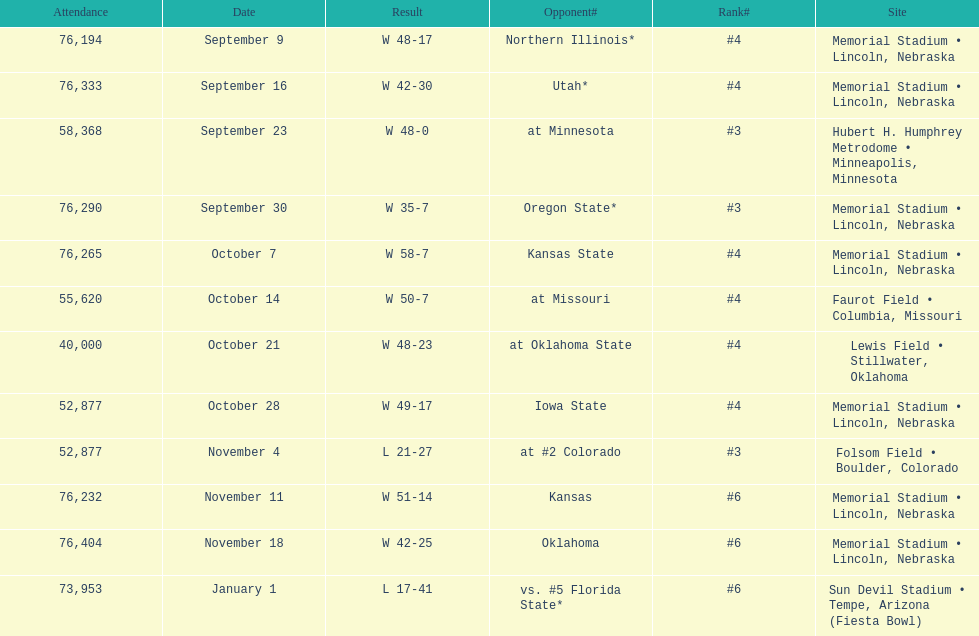How many games was their ranking not lower than #5? 9. 